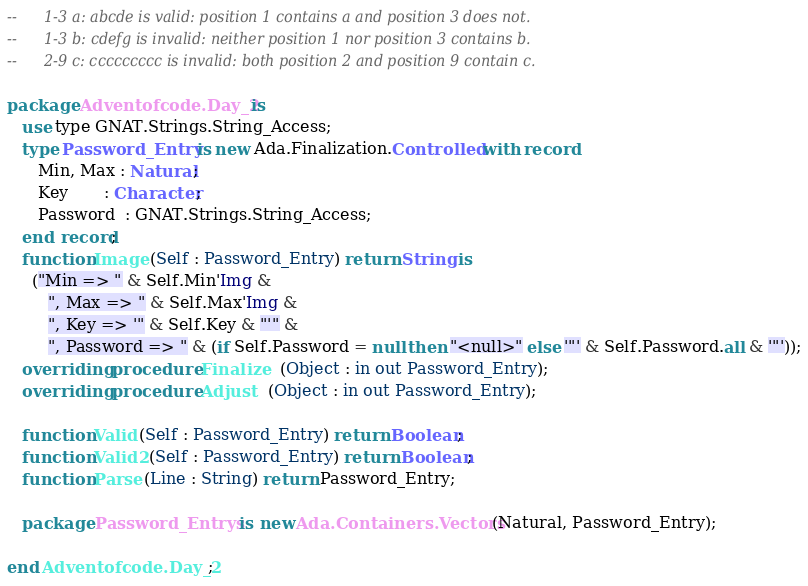Convert code to text. <code><loc_0><loc_0><loc_500><loc_500><_Ada_>--      1-3 a: abcde is valid: position 1 contains a and position 3 does not.
--      1-3 b: cdefg is invalid: neither position 1 nor position 3 contains b.
--      2-9 c: ccccccccc is invalid: both position 2 and position 9 contain c.

package Adventofcode.Day_2 is
   use type GNAT.Strings.String_Access;
   type Password_Entry is new Ada.Finalization.Controlled with record
      Min, Max : Natural;
      Key       : Character;
      Password  : GNAT.Strings.String_Access;
   end record;
   function Image (Self : Password_Entry) return String is
     ("Min => " & Self.Min'Img &
        ", Max => " & Self.Max'Img &
        ", Key => '" & Self.Key & "'" &
        ", Password => " & (if Self.Password = null then "<null>" else '"' & Self.Password.all & '"'));
   overriding procedure Finalize   (Object : in out Password_Entry);
   overriding procedure Adjust   (Object : in out Password_Entry);

   function Valid (Self : Password_Entry) return Boolean;
   function Valid2 (Self : Password_Entry) return Boolean;
   function Parse (Line : String) return Password_Entry;

   package Password_Entrys is new Ada.Containers.Vectors (Natural, Password_Entry);

end Adventofcode.Day_2;
</code> 